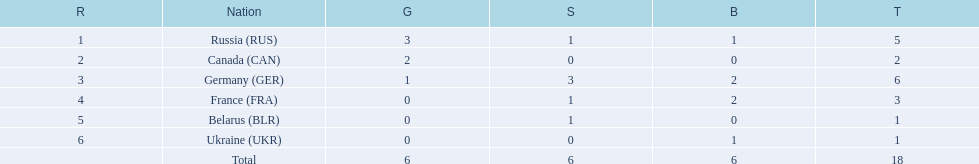What were all the countries that won biathlon medals? Russia (RUS), Canada (CAN), Germany (GER), France (FRA), Belarus (BLR), Ukraine (UKR). What were their medal counts? 5, 2, 6, 3, 1, 1. Of these, which is the largest number of medals? 6. Which country won this number of medals? Germany (GER). 